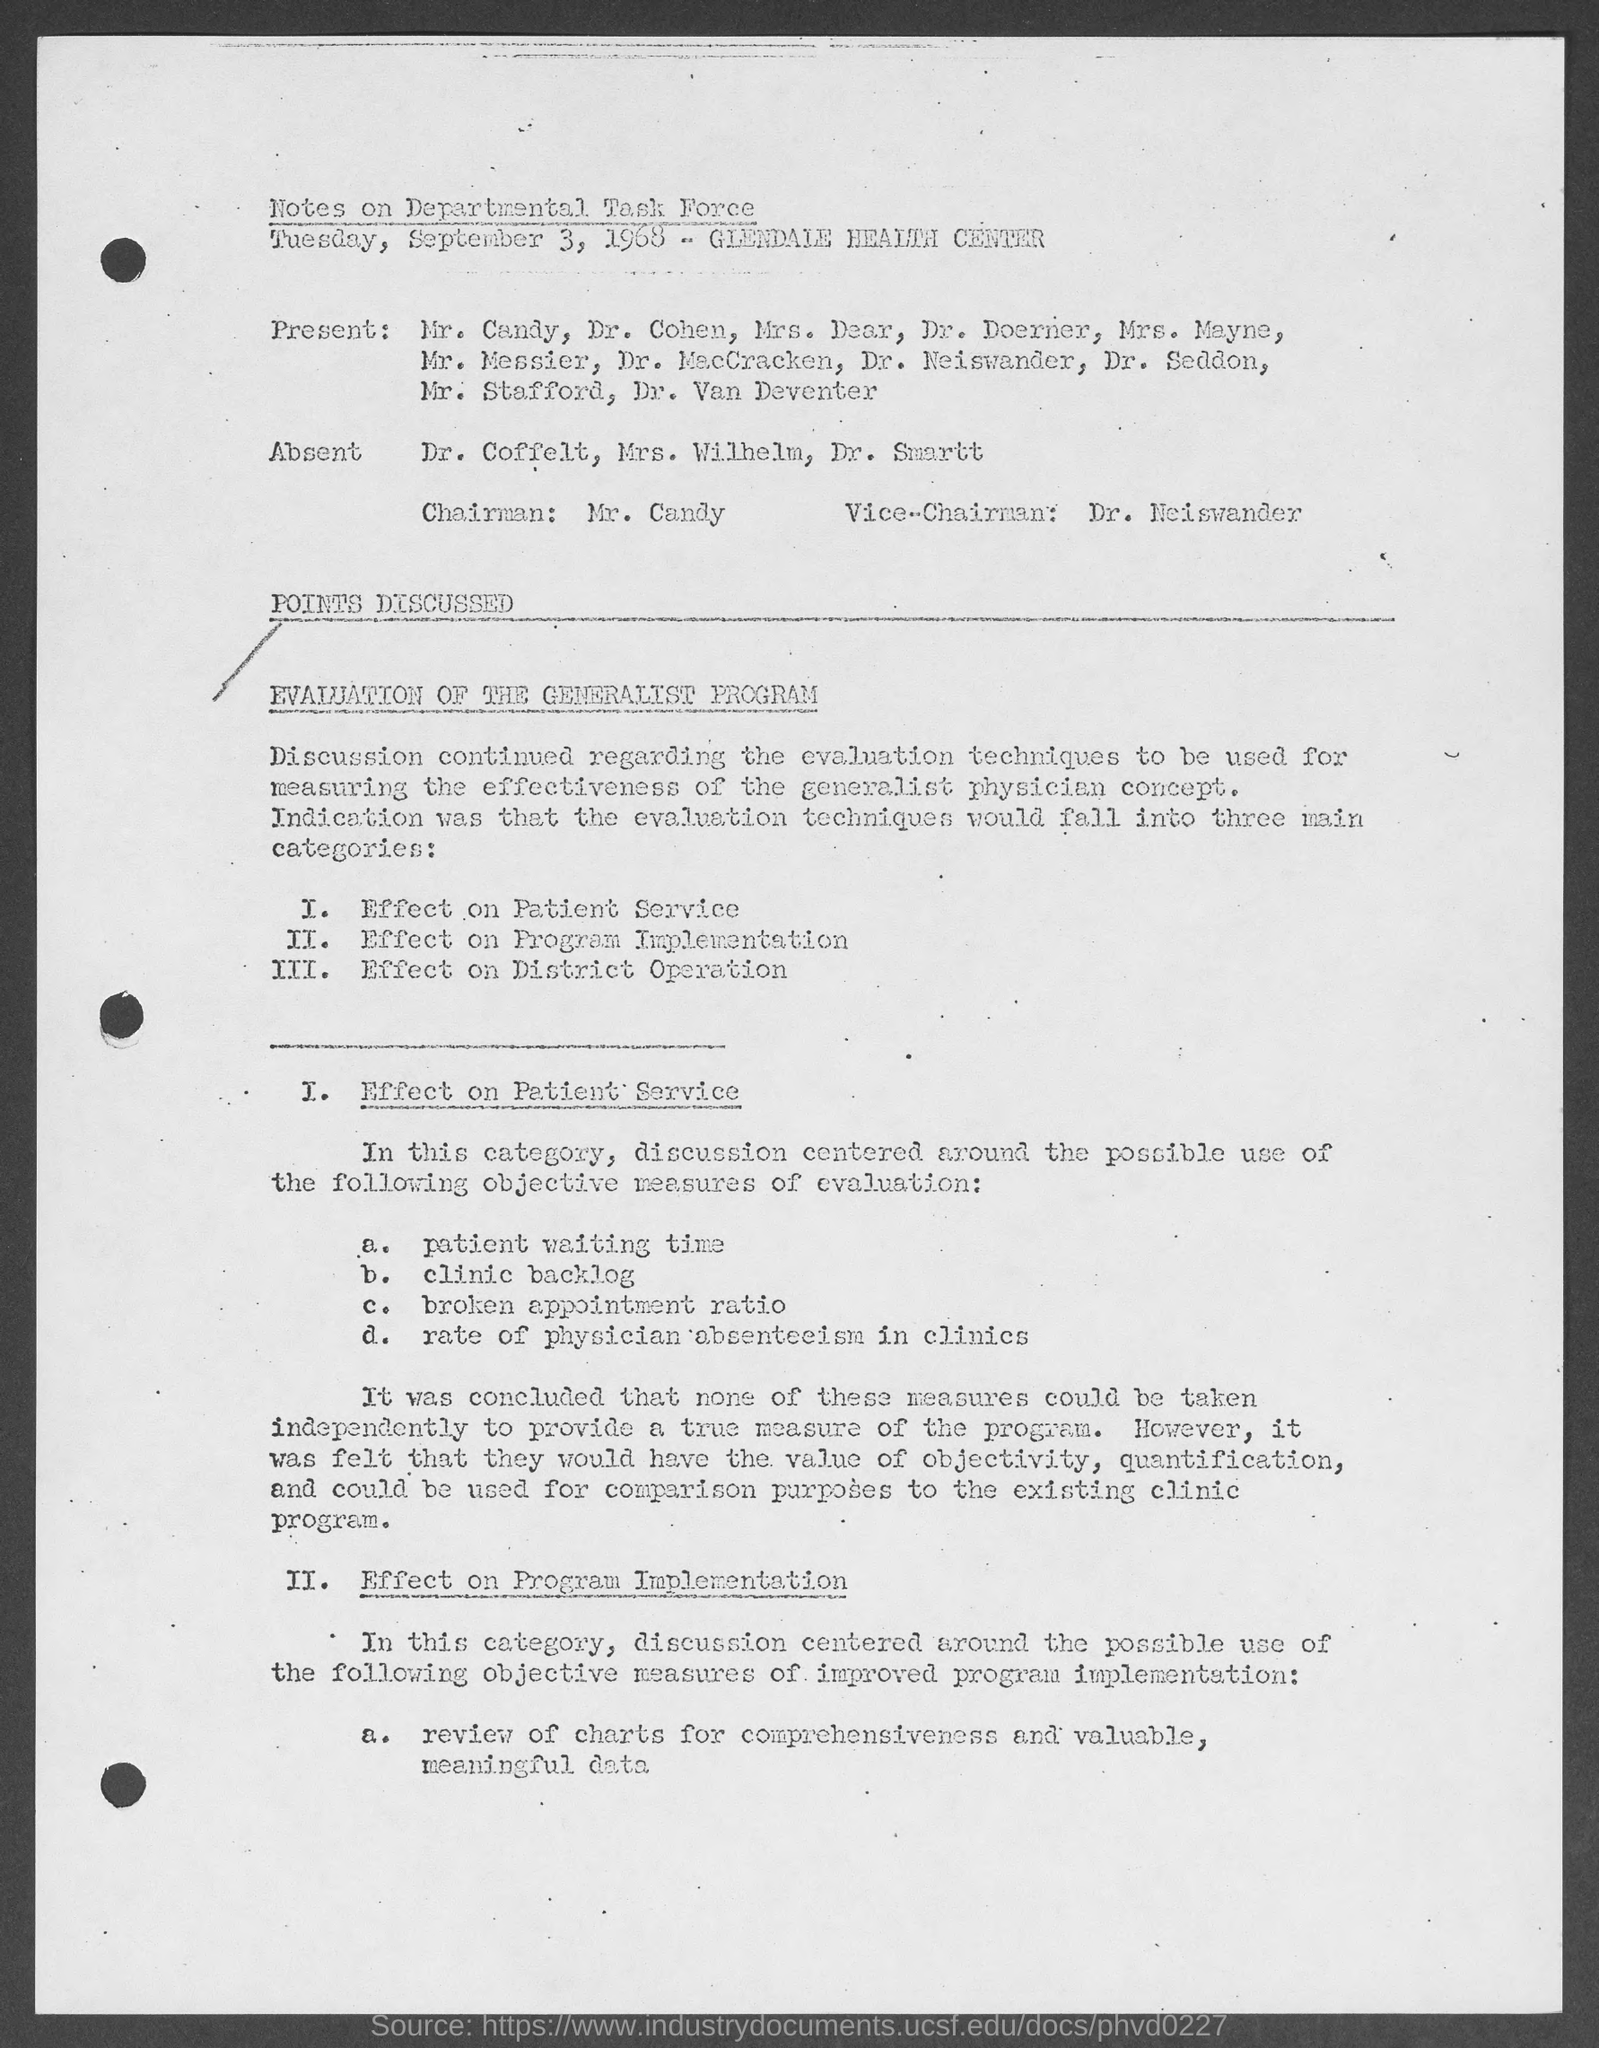Who was absent from the meeting? According to the document, the individuals absent from the meeting were Dr. Cofelt, Mrs. Wilhelm, and Dr. Snurtt. 